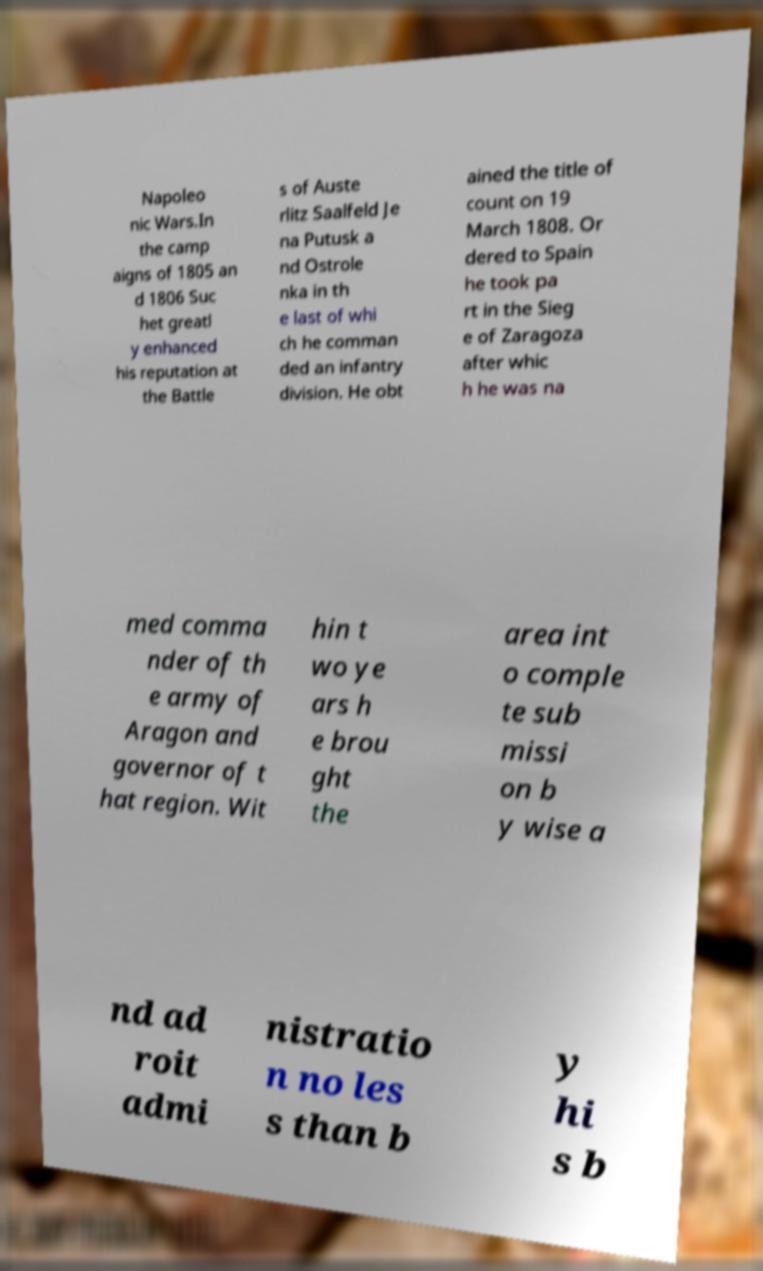Could you extract and type out the text from this image? Napoleo nic Wars.In the camp aigns of 1805 an d 1806 Suc het greatl y enhanced his reputation at the Battle s of Auste rlitz Saalfeld Je na Putusk a nd Ostrole nka in th e last of whi ch he comman ded an infantry division. He obt ained the title of count on 19 March 1808. Or dered to Spain he took pa rt in the Sieg e of Zaragoza after whic h he was na med comma nder of th e army of Aragon and governor of t hat region. Wit hin t wo ye ars h e brou ght the area int o comple te sub missi on b y wise a nd ad roit admi nistratio n no les s than b y hi s b 